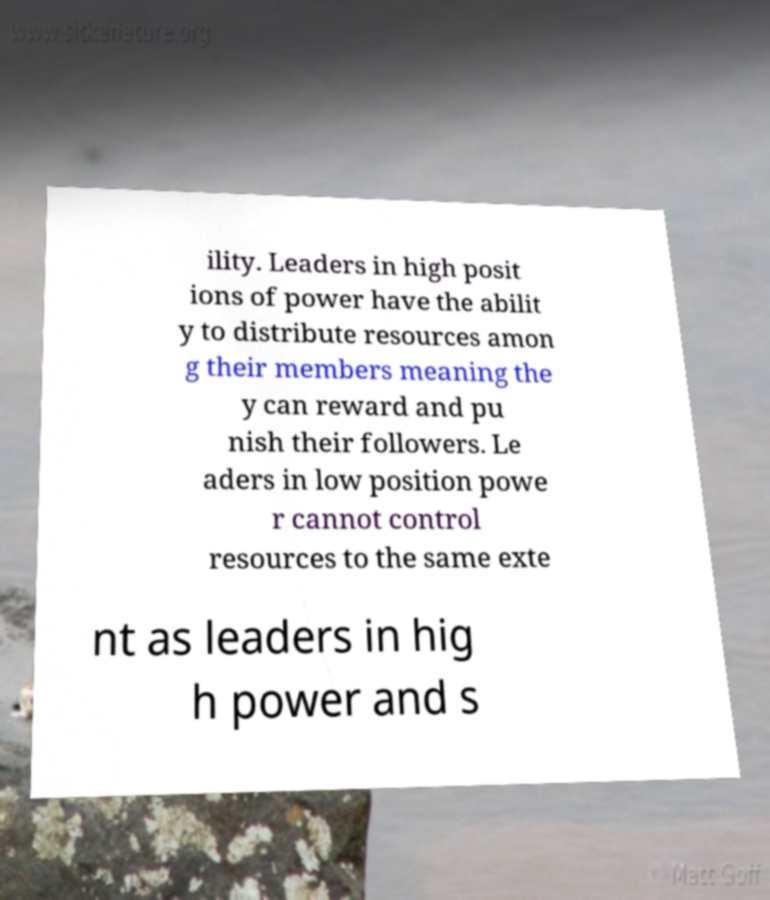Can you accurately transcribe the text from the provided image for me? ility. Leaders in high posit ions of power have the abilit y to distribute resources amon g their members meaning the y can reward and pu nish their followers. Le aders in low position powe r cannot control resources to the same exte nt as leaders in hig h power and s 